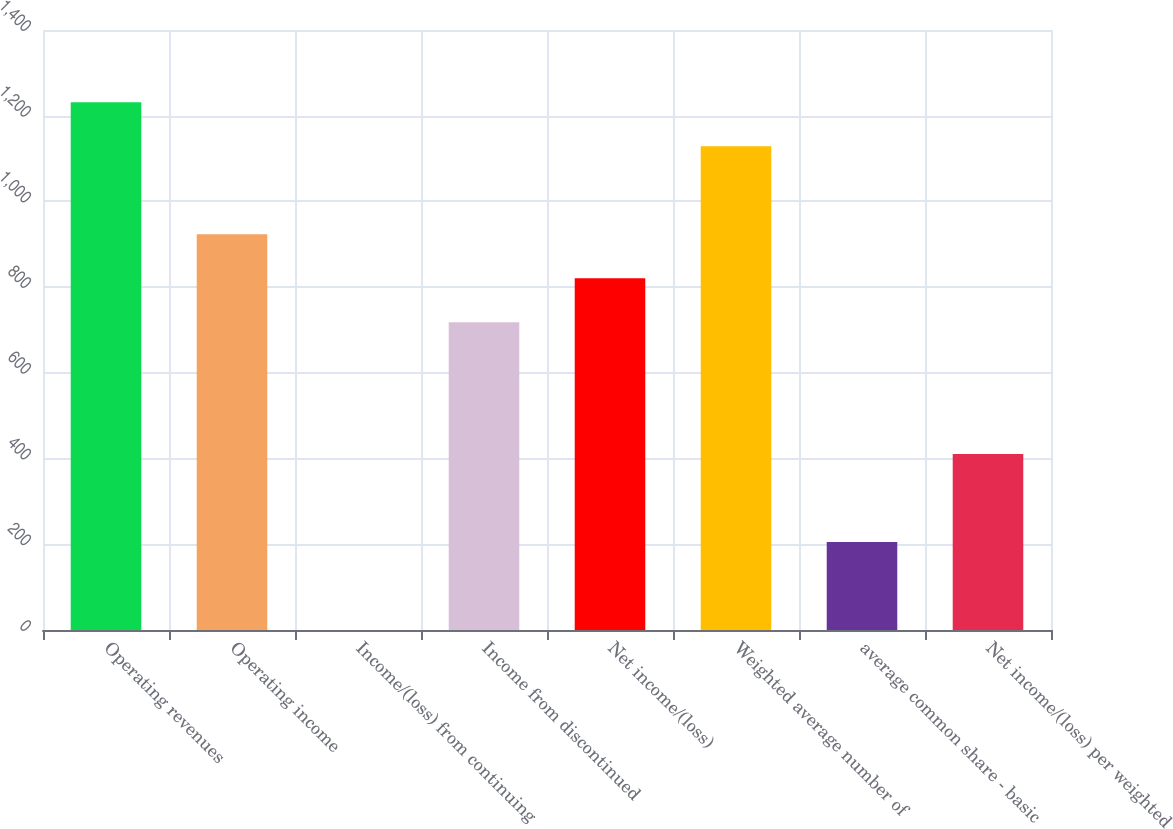Convert chart. <chart><loc_0><loc_0><loc_500><loc_500><bar_chart><fcel>Operating revenues<fcel>Operating income<fcel>Income/(loss) from continuing<fcel>Income from discontinued<fcel>Net income/(loss)<fcel>Weighted average number of<fcel>average common share - basic<fcel>Net income/(loss) per weighted<nl><fcel>1231.21<fcel>923.41<fcel>0.01<fcel>718.21<fcel>820.81<fcel>1128.61<fcel>205.21<fcel>410.41<nl></chart> 